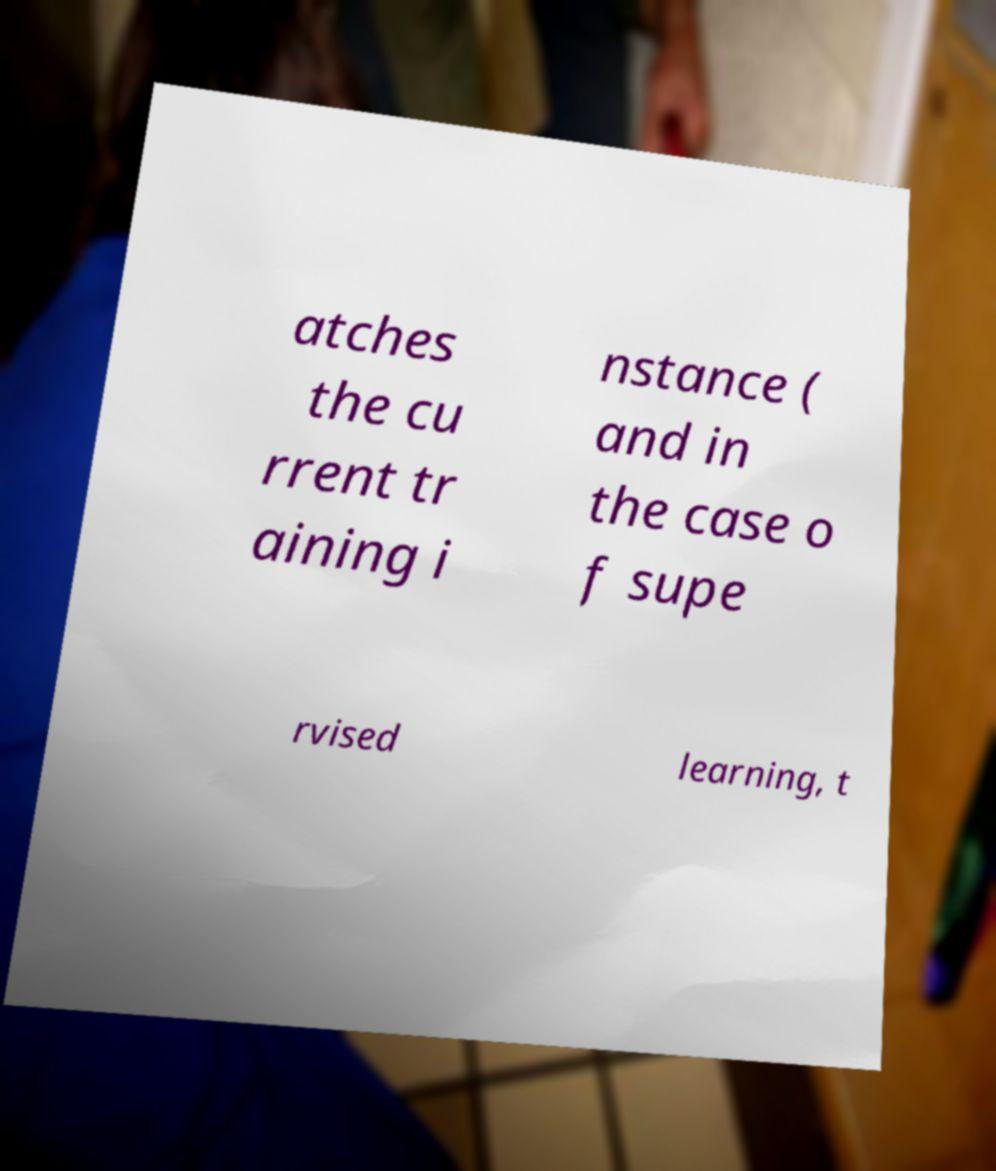For documentation purposes, I need the text within this image transcribed. Could you provide that? atches the cu rrent tr aining i nstance ( and in the case o f supe rvised learning, t 